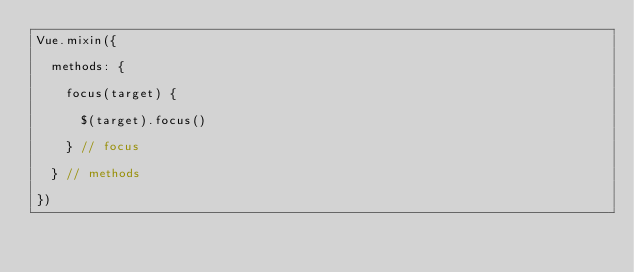<code> <loc_0><loc_0><loc_500><loc_500><_JavaScript_>Vue.mixin({

  methods: {

    focus(target) {

      $(target).focus()

    } // focus

  } // methods

})</code> 